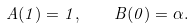<formula> <loc_0><loc_0><loc_500><loc_500>A ( 1 ) = 1 , \quad B ( 0 ) = \alpha .</formula> 